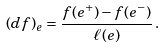Convert formula to latex. <formula><loc_0><loc_0><loc_500><loc_500>( d f ) _ { e } = \frac { f ( e ^ { + } ) - f ( e ^ { - } ) } { \ell ( e ) } \, .</formula> 